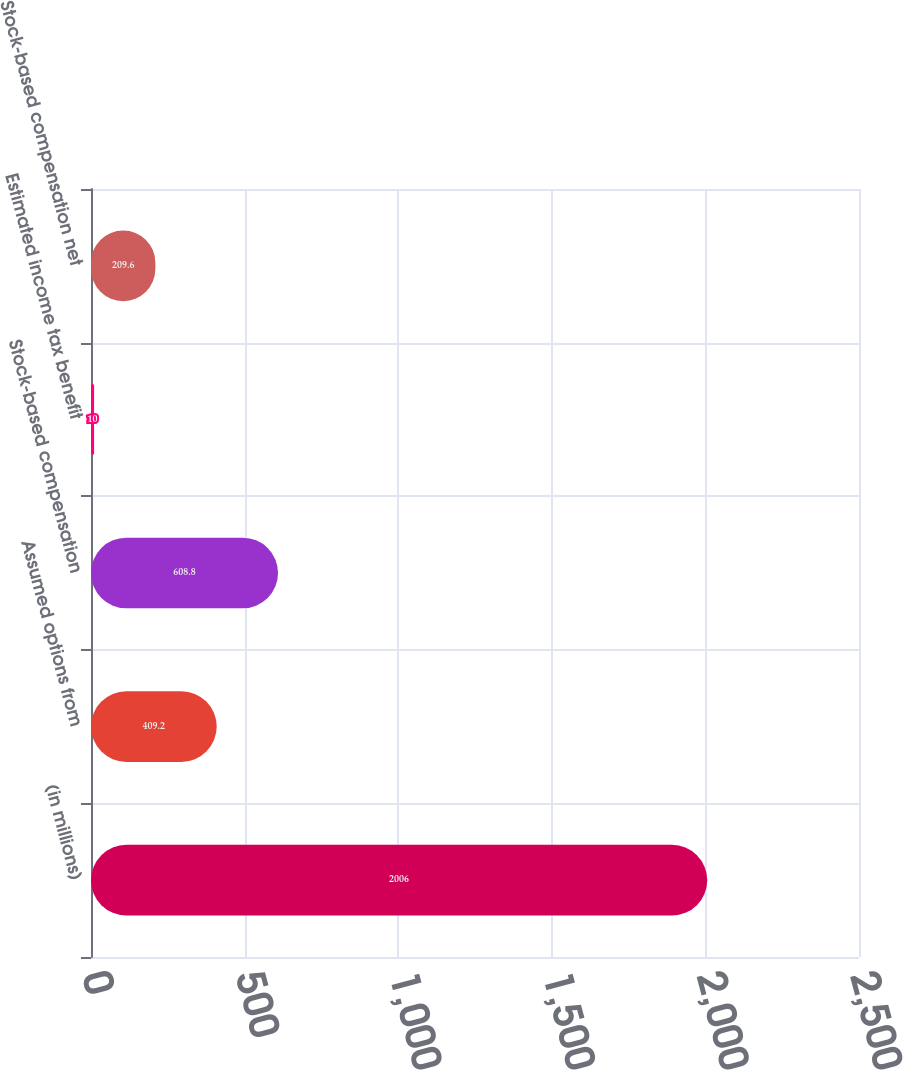Convert chart. <chart><loc_0><loc_0><loc_500><loc_500><bar_chart><fcel>(in millions)<fcel>Assumed options from<fcel>Stock-based compensation<fcel>Estimated income tax benefit<fcel>Stock-based compensation net<nl><fcel>2006<fcel>409.2<fcel>608.8<fcel>10<fcel>209.6<nl></chart> 